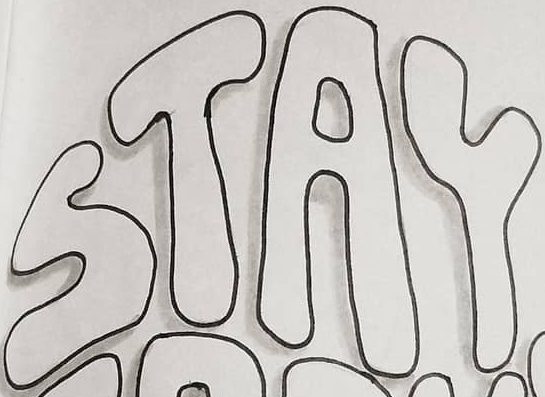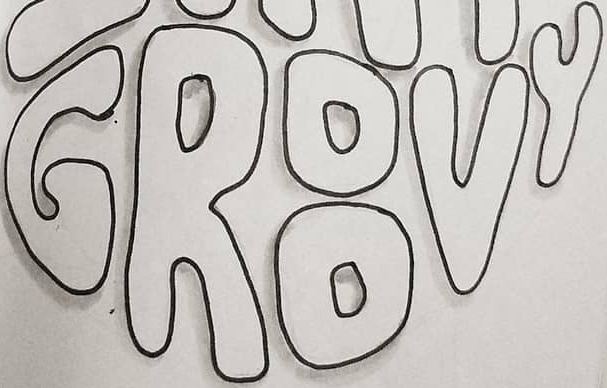Identify the words shown in these images in order, separated by a semicolon. STAY; GROOVY 